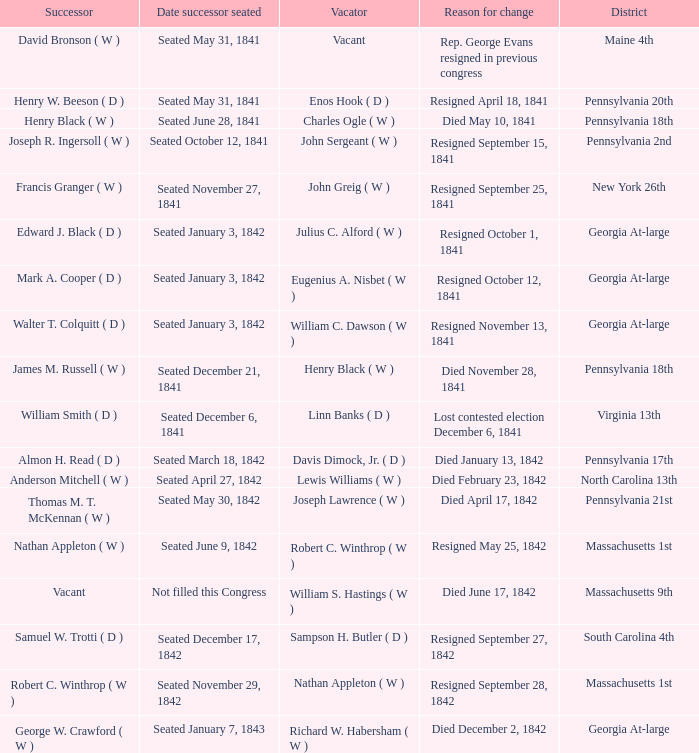Write the full table. {'header': ['Successor', 'Date successor seated', 'Vacator', 'Reason for change', 'District'], 'rows': [['David Bronson ( W )', 'Seated May 31, 1841', 'Vacant', 'Rep. George Evans resigned in previous congress', 'Maine 4th'], ['Henry W. Beeson ( D )', 'Seated May 31, 1841', 'Enos Hook ( D )', 'Resigned April 18, 1841', 'Pennsylvania 20th'], ['Henry Black ( W )', 'Seated June 28, 1841', 'Charles Ogle ( W )', 'Died May 10, 1841', 'Pennsylvania 18th'], ['Joseph R. Ingersoll ( W )', 'Seated October 12, 1841', 'John Sergeant ( W )', 'Resigned September 15, 1841', 'Pennsylvania 2nd'], ['Francis Granger ( W )', 'Seated November 27, 1841', 'John Greig ( W )', 'Resigned September 25, 1841', 'New York 26th'], ['Edward J. Black ( D )', 'Seated January 3, 1842', 'Julius C. Alford ( W )', 'Resigned October 1, 1841', 'Georgia At-large'], ['Mark A. Cooper ( D )', 'Seated January 3, 1842', 'Eugenius A. Nisbet ( W )', 'Resigned October 12, 1841', 'Georgia At-large'], ['Walter T. Colquitt ( D )', 'Seated January 3, 1842', 'William C. Dawson ( W )', 'Resigned November 13, 1841', 'Georgia At-large'], ['James M. Russell ( W )', 'Seated December 21, 1841', 'Henry Black ( W )', 'Died November 28, 1841', 'Pennsylvania 18th'], ['William Smith ( D )', 'Seated December 6, 1841', 'Linn Banks ( D )', 'Lost contested election December 6, 1841', 'Virginia 13th'], ['Almon H. Read ( D )', 'Seated March 18, 1842', 'Davis Dimock, Jr. ( D )', 'Died January 13, 1842', 'Pennsylvania 17th'], ['Anderson Mitchell ( W )', 'Seated April 27, 1842', 'Lewis Williams ( W )', 'Died February 23, 1842', 'North Carolina 13th'], ['Thomas M. T. McKennan ( W )', 'Seated May 30, 1842', 'Joseph Lawrence ( W )', 'Died April 17, 1842', 'Pennsylvania 21st'], ['Nathan Appleton ( W )', 'Seated June 9, 1842', 'Robert C. Winthrop ( W )', 'Resigned May 25, 1842', 'Massachusetts 1st'], ['Vacant', 'Not filled this Congress', 'William S. Hastings ( W )', 'Died June 17, 1842', 'Massachusetts 9th'], ['Samuel W. Trotti ( D )', 'Seated December 17, 1842', 'Sampson H. Butler ( D )', 'Resigned September 27, 1842', 'South Carolina 4th'], ['Robert C. Winthrop ( W )', 'Seated November 29, 1842', 'Nathan Appleton ( W )', 'Resigned September 28, 1842', 'Massachusetts 1st'], ['George W. Crawford ( W )', 'Seated January 7, 1843', 'Richard W. Habersham ( W )', 'Died December 2, 1842', 'Georgia At-large']]} Name the date successor seated for pennsylvania 17th Seated March 18, 1842. 